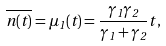<formula> <loc_0><loc_0><loc_500><loc_500>\overline { n ( t ) } = \mu _ { 1 } ( t ) = \frac { \gamma _ { 1 } \gamma _ { 2 } } { \gamma _ { 1 } + \gamma _ { 2 } } t \, ,</formula> 